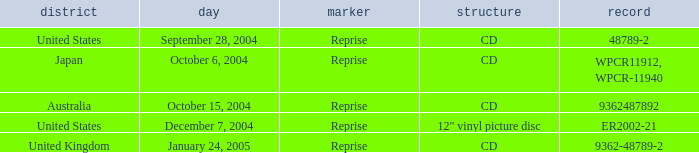Name the october 15, 2004 catalogue 9362487892.0. 